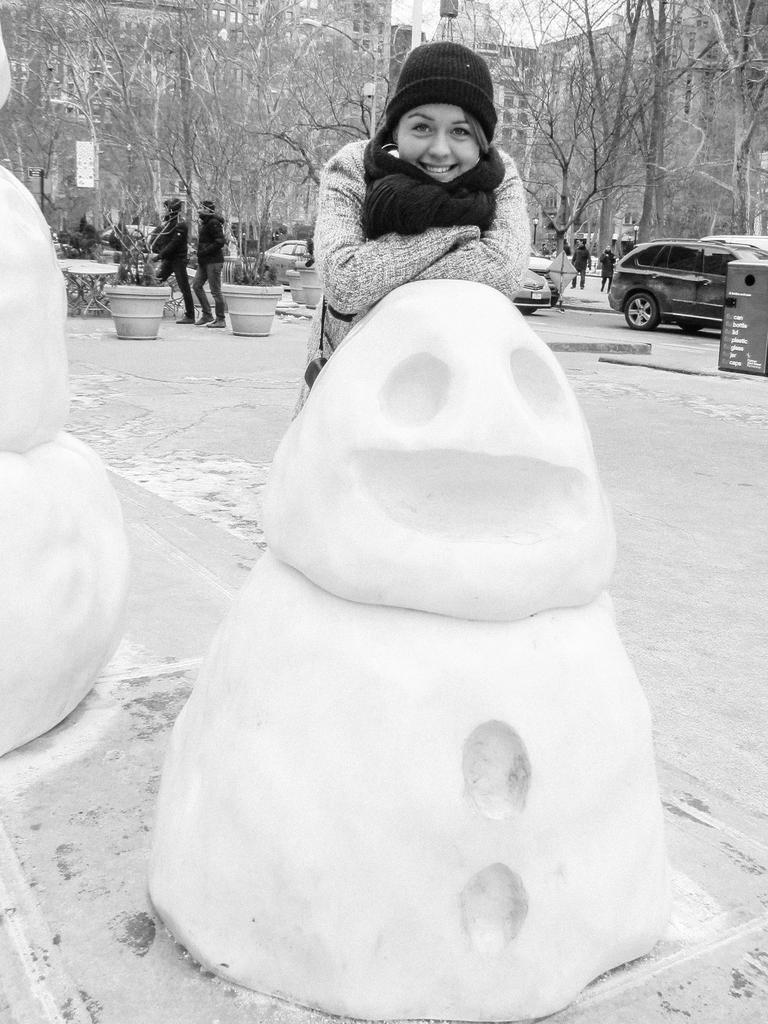Who is the main subject in the image? The main subject in the image is a lady. What is the lady wearing on her head? The lady is wearing a cap. What is the lady wearing around her neck? The lady is wearing a scarf. What is the lady's facial expression in the image? The lady is smiling. What is the lady standing near in the image? The lady is standing near a snowman. What can be seen in the background of the image? In the background, there is a pot with plants, trees, people, and vehicles. What is the lady's interest in chin music in the image? There is no mention of chin music or any interest in it in the image. 